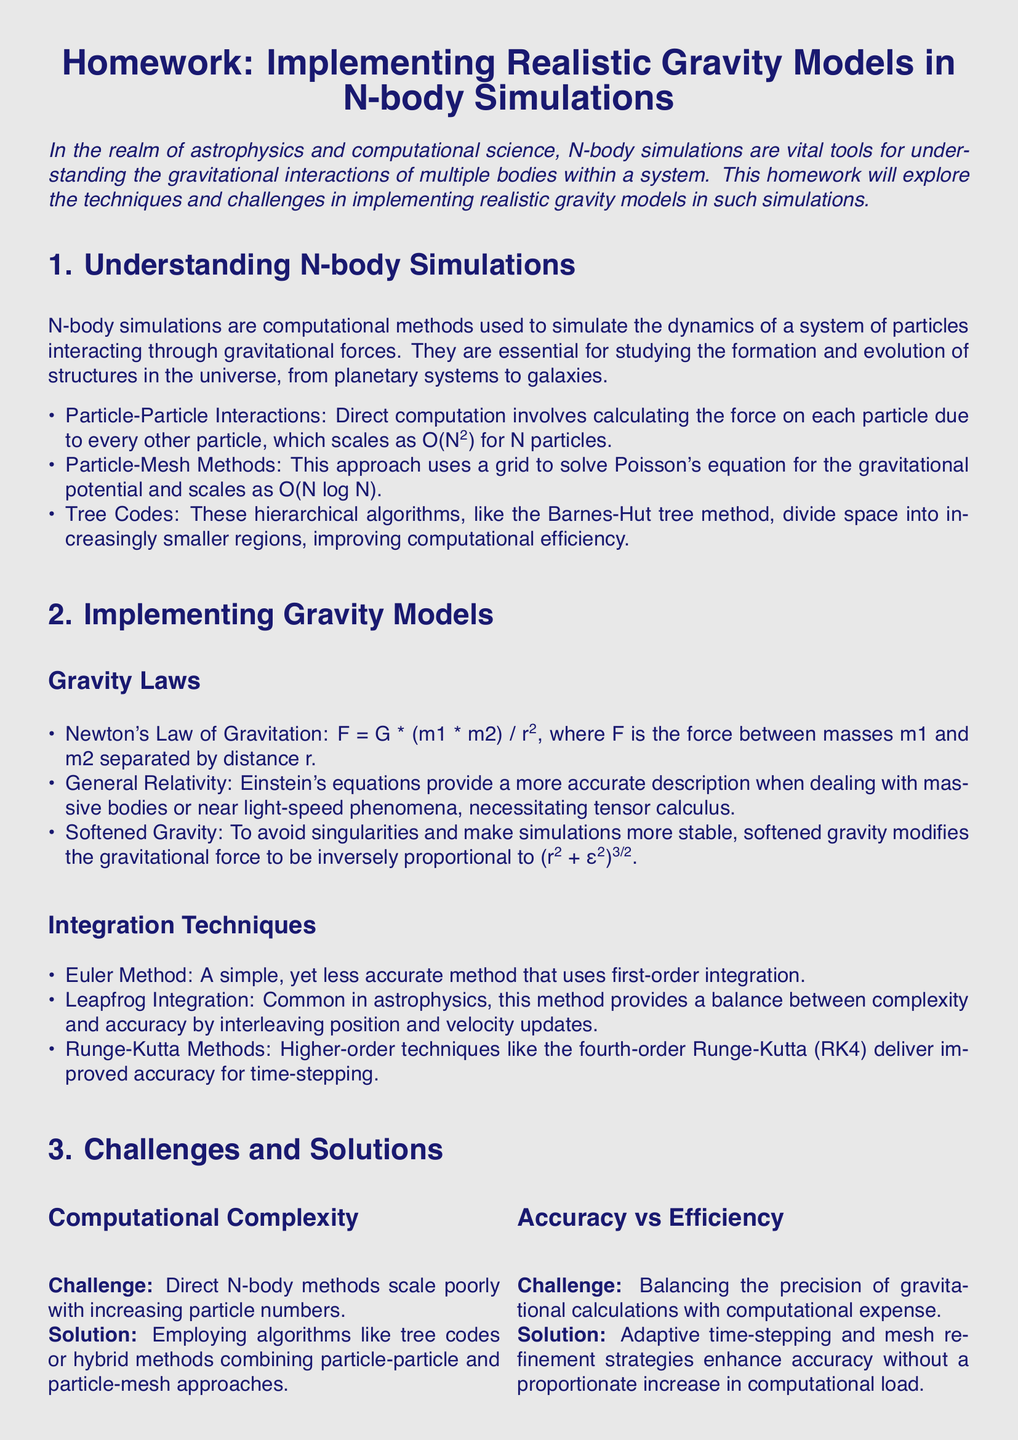What is the main focus of the homework? The document outlines that the homework focuses on implementing realistic gravity models in N-body simulations, exploring techniques and challenges.
Answer: Implementing realistic gravity models in N-body simulations What is one algorithm mentioned for improving computational efficiency in N-body simulations? The document lists tree codes, like the Barnes-Hut tree method, as a hierarchical algorithm that aids in computational efficiency.
Answer: Tree codes What is the formula for Newton's Law of Gravitation provided in the document? The formula for Newton's Law of Gravitation given in the document is F = G * (m1 * m2) / r².
Answer: F = G * (m1 * m2) / r² What is the challenge related to direct N-body methods in terms of computational complexity? The document states that direct N-body methods scale poorly with increasing particle numbers, which is a significant challenge.
Answer: Scale poorly Which integration method is commonly used in astrophysics for its balance between complexity and accuracy? The document mentions the Leapfrog Integration method as commonly used for balancing complexity and accuracy.
Answer: Leapfrog Integration How do softened gravity modifications help in simulations? The document explains that softened gravity helps to avoid singularities, making simulations more stable.
Answer: Avoid singularities What is a solution provided for setting appropriate boundary conditions? The document suggests implementing periodic boundaries for cosmological simulations or reflective/absorptive boundaries for confined systems as a solution.
Answer: Periodic boundaries Which reference work focuses on Galactic Dynamics according to the homework? The homework lists "Galactic Dynamics" by Binney and Tremaine as a reference work.
Answer: Galactic Dynamics What does the integration technique Runge-Kutta improve in simulations? The document states that higher-order techniques like the fourth-order Runge-Kutta improve accuracy for time-stepping.
Answer: Accuracy 